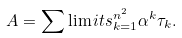<formula> <loc_0><loc_0><loc_500><loc_500>A = \sum \lim i t s _ { k = 1 } ^ { n ^ { 2 } } \alpha ^ { k } \tau _ { k } .</formula> 